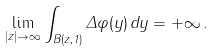<formula> <loc_0><loc_0><loc_500><loc_500>\lim _ { | z | \rightarrow \infty } \int _ { B ( z , 1 ) } \Delta \varphi ( y ) \, d y = + \infty \, .</formula> 